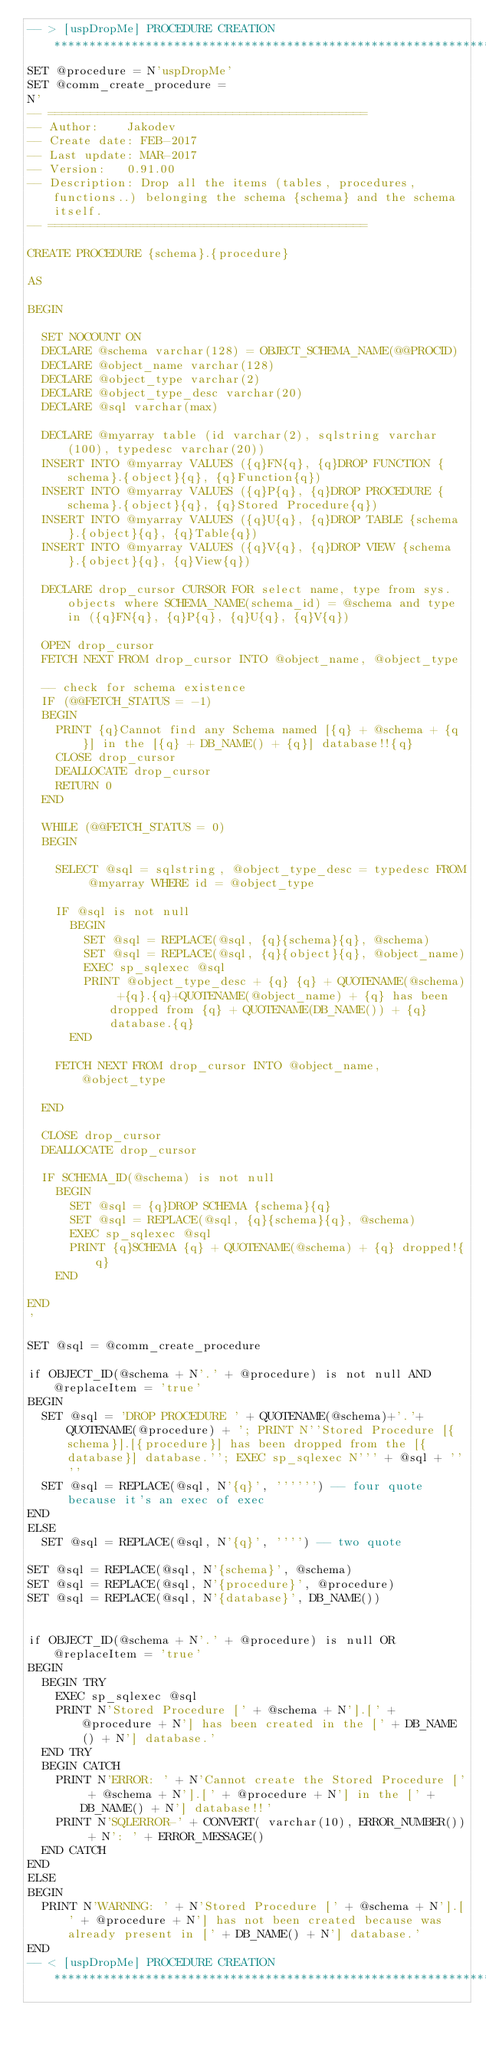Convert code to text. <code><loc_0><loc_0><loc_500><loc_500><_SQL_>-- > [uspDropMe] PROCEDURE CREATION		*************************************************************************************************************
SET @procedure = N'uspDropMe'
SET @comm_create_procedure =
N'
-- =============================================
-- Author:		Jakodev
-- Create date: FEB-2017
-- Last update:	MAR-2017
-- Version:		0.91.00
-- Description:	Drop all the items (tables, procedures, functions..) belonging the schema {schema} and the schema itself.
-- =============================================

CREATE PROCEDURE {schema}.{procedure}

AS

BEGIN
	
	SET NOCOUNT ON
	DECLARE @schema varchar(128) = OBJECT_SCHEMA_NAME(@@PROCID)
	DECLARE @object_name varchar(128)
	DECLARE @object_type varchar(2)
	DECLARE @object_type_desc varchar(20)
	DECLARE @sql varchar(max)

	DECLARE @myarray table (id varchar(2), sqlstring varchar(100), typedesc varchar(20))
	INSERT INTO @myarray VALUES ({q}FN{q}, {q}DROP FUNCTION {schema}.{object}{q}, {q}Function{q}) 
	INSERT INTO @myarray VALUES ({q}P{q}, {q}DROP PROCEDURE {schema}.{object}{q}, {q}Stored Procedure{q})
	INSERT INTO @myarray VALUES ({q}U{q}, {q}DROP TABLE {schema}.{object}{q}, {q}Table{q})
	INSERT INTO @myarray VALUES ({q}V{q}, {q}DROP VIEW {schema}.{object}{q}, {q}View{q})

	DECLARE drop_cursor CURSOR FOR select name, type from sys.objects where SCHEMA_NAME(schema_id) = @schema and type in ({q}FN{q}, {q}P{q}, {q}U{q}, {q}V{q})

	OPEN drop_cursor
	FETCH NEXT FROM drop_cursor INTO @object_name, @object_type

	-- check for schema existence
	IF (@@FETCH_STATUS = -1)
	BEGIN
		PRINT {q}Cannot find any Schema named [{q} + @schema + {q}] in the [{q} + DB_NAME() + {q}] database!!{q}
		CLOSE drop_cursor
		DEALLOCATE drop_cursor
		RETURN 0
	END 

	WHILE (@@FETCH_STATUS = 0)
	BEGIN

		SELECT @sql = sqlstring, @object_type_desc = typedesc FROM @myarray WHERE id = @object_type

		IF @sql is not null
			BEGIN
				SET @sql = REPLACE(@sql, {q}{schema}{q}, @schema)
				SET @sql = REPLACE(@sql, {q}{object}{q}, @object_name)
				EXEC sp_sqlexec @sql
				PRINT @object_type_desc + {q} {q} + QUOTENAME(@schema) +{q}.{q}+QUOTENAME(@object_name) + {q} has been dropped from {q} + QUOTENAME(DB_NAME()) + {q} database.{q}
			END	

		FETCH NEXT FROM drop_cursor INTO @object_name, @object_type

	END

	CLOSE drop_cursor
	DEALLOCATE drop_cursor

	IF SCHEMA_ID(@schema) is not null
		BEGIN
			SET @sql = {q}DROP SCHEMA {schema}{q}
			SET @sql = REPLACE(@sql, {q}{schema}{q}, @schema)
			EXEC sp_sqlexec @sql
			PRINT {q}SCHEMA {q} + QUOTENAME(@schema) + {q} dropped!{q}
		END
		
END
'

SET @sql = @comm_create_procedure

if OBJECT_ID(@schema + N'.' + @procedure) is not null AND @replaceItem = 'true'
BEGIN
	SET @sql = 'DROP PROCEDURE ' + QUOTENAME(@schema)+'.'+QUOTENAME(@procedure) + '; PRINT N''Stored Procedure [{schema}].[{procedure}] has been dropped from the [{database}] database.''; EXEC sp_sqlexec N''' + @sql + ''''
	SET @sql = REPLACE(@sql, N'{q}', '''''') -- four quote because it's an exec of exec
END
ELSE
	SET @sql = REPLACE(@sql, N'{q}', '''') -- two quote
	
SET @sql = REPLACE(@sql, N'{schema}', @schema)
SET @sql = REPLACE(@sql, N'{procedure}', @procedure)
SET @sql = REPLACE(@sql, N'{database}', DB_NAME())


if OBJECT_ID(@schema + N'.' + @procedure) is null OR @replaceItem = 'true'
BEGIN
	BEGIN TRY
		EXEC sp_sqlexec @sql
		PRINT N'Stored Procedure [' + @schema + N'].[' + @procedure + N'] has been created in the [' + DB_NAME() + N'] database.'
	END TRY
	BEGIN CATCH
		PRINT N'ERROR: ' + N'Cannot create the Stored Procedure [' + @schema + N'].[' + @procedure + N'] in the [' + DB_NAME() + N'] database!!'
		PRINT N'SQLERROR-' + CONVERT( varchar(10), ERROR_NUMBER()) + N': ' + ERROR_MESSAGE()
	END CATCH
END
ELSE
BEGIN
	PRINT N'WARNING: ' + N'Stored Procedure [' + @schema + N'].[' + @procedure + N'] has not been created because was already present in [' + DB_NAME() + N'] database.'
END
-- < [uspDropMe] PROCEDURE CREATION		*************************************************************************************************************
</code> 